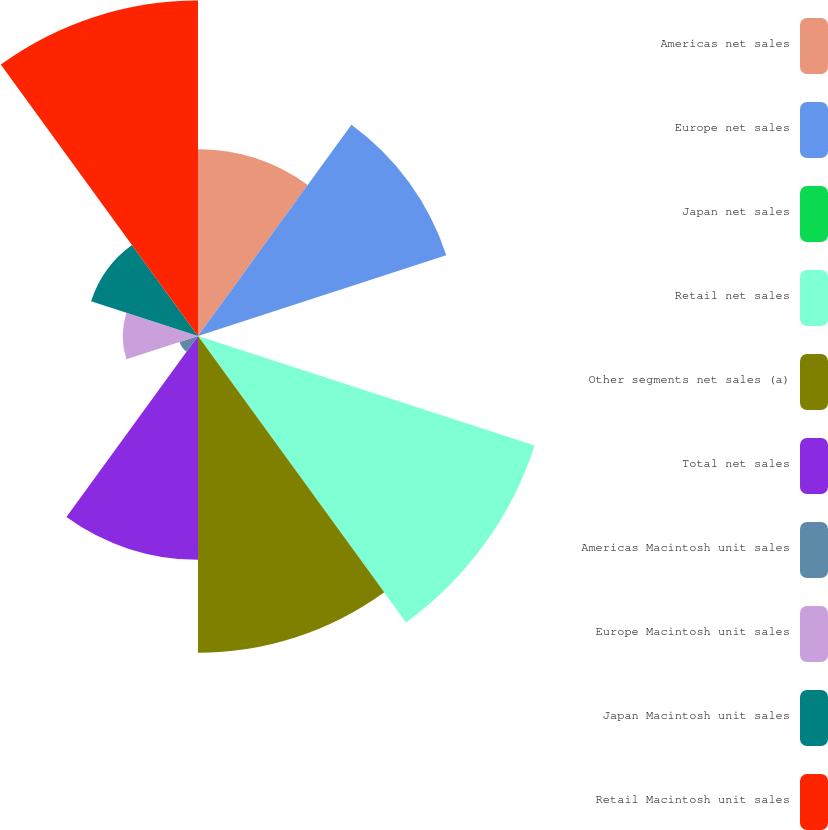<chart> <loc_0><loc_0><loc_500><loc_500><pie_chart><fcel>Americas net sales<fcel>Europe net sales<fcel>Japan net sales<fcel>Retail net sales<fcel>Other segments net sales (a)<fcel>Total net sales<fcel>Americas Macintosh unit sales<fcel>Europe Macintosh unit sales<fcel>Japan Macintosh unit sales<fcel>Retail Macintosh unit sales<nl><fcel>9.9%<fcel>13.84%<fcel>0.04%<fcel>18.77%<fcel>16.8%<fcel>11.87%<fcel>1.03%<fcel>3.99%<fcel>5.96%<fcel>17.79%<nl></chart> 